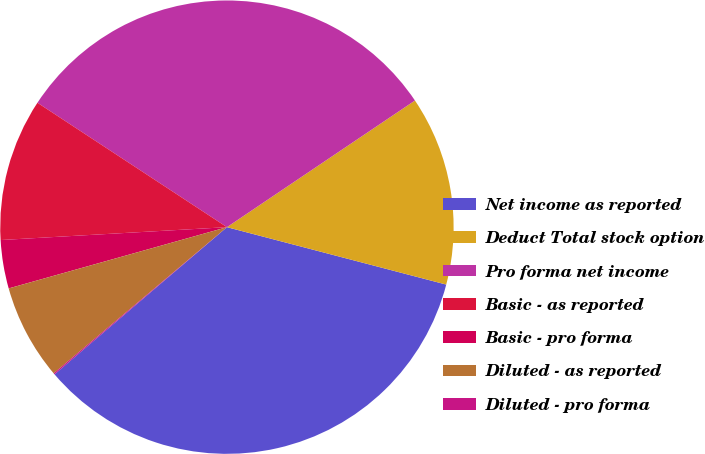Convert chart to OTSL. <chart><loc_0><loc_0><loc_500><loc_500><pie_chart><fcel>Net income as reported<fcel>Deduct Total stock option<fcel>Pro forma net income<fcel>Basic - as reported<fcel>Basic - pro forma<fcel>Diluted - as reported<fcel>Diluted - pro forma<nl><fcel>34.68%<fcel>13.51%<fcel>31.32%<fcel>10.15%<fcel>3.45%<fcel>6.8%<fcel>0.09%<nl></chart> 